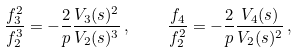<formula> <loc_0><loc_0><loc_500><loc_500>\frac { f _ { 3 } ^ { 2 } } { f _ { 2 } ^ { 3 } } = - \frac { 2 } { p } \frac { V _ { 3 } ( s ) ^ { 2 } } { V _ { 2 } ( s ) ^ { 3 } } \, , \quad \frac { f _ { 4 } } { f _ { 2 } ^ { 2 } } = - \frac { 2 } { p } \frac { V _ { 4 } ( s ) } { V _ { 2 } ( s ) ^ { 2 } } \, ,</formula> 